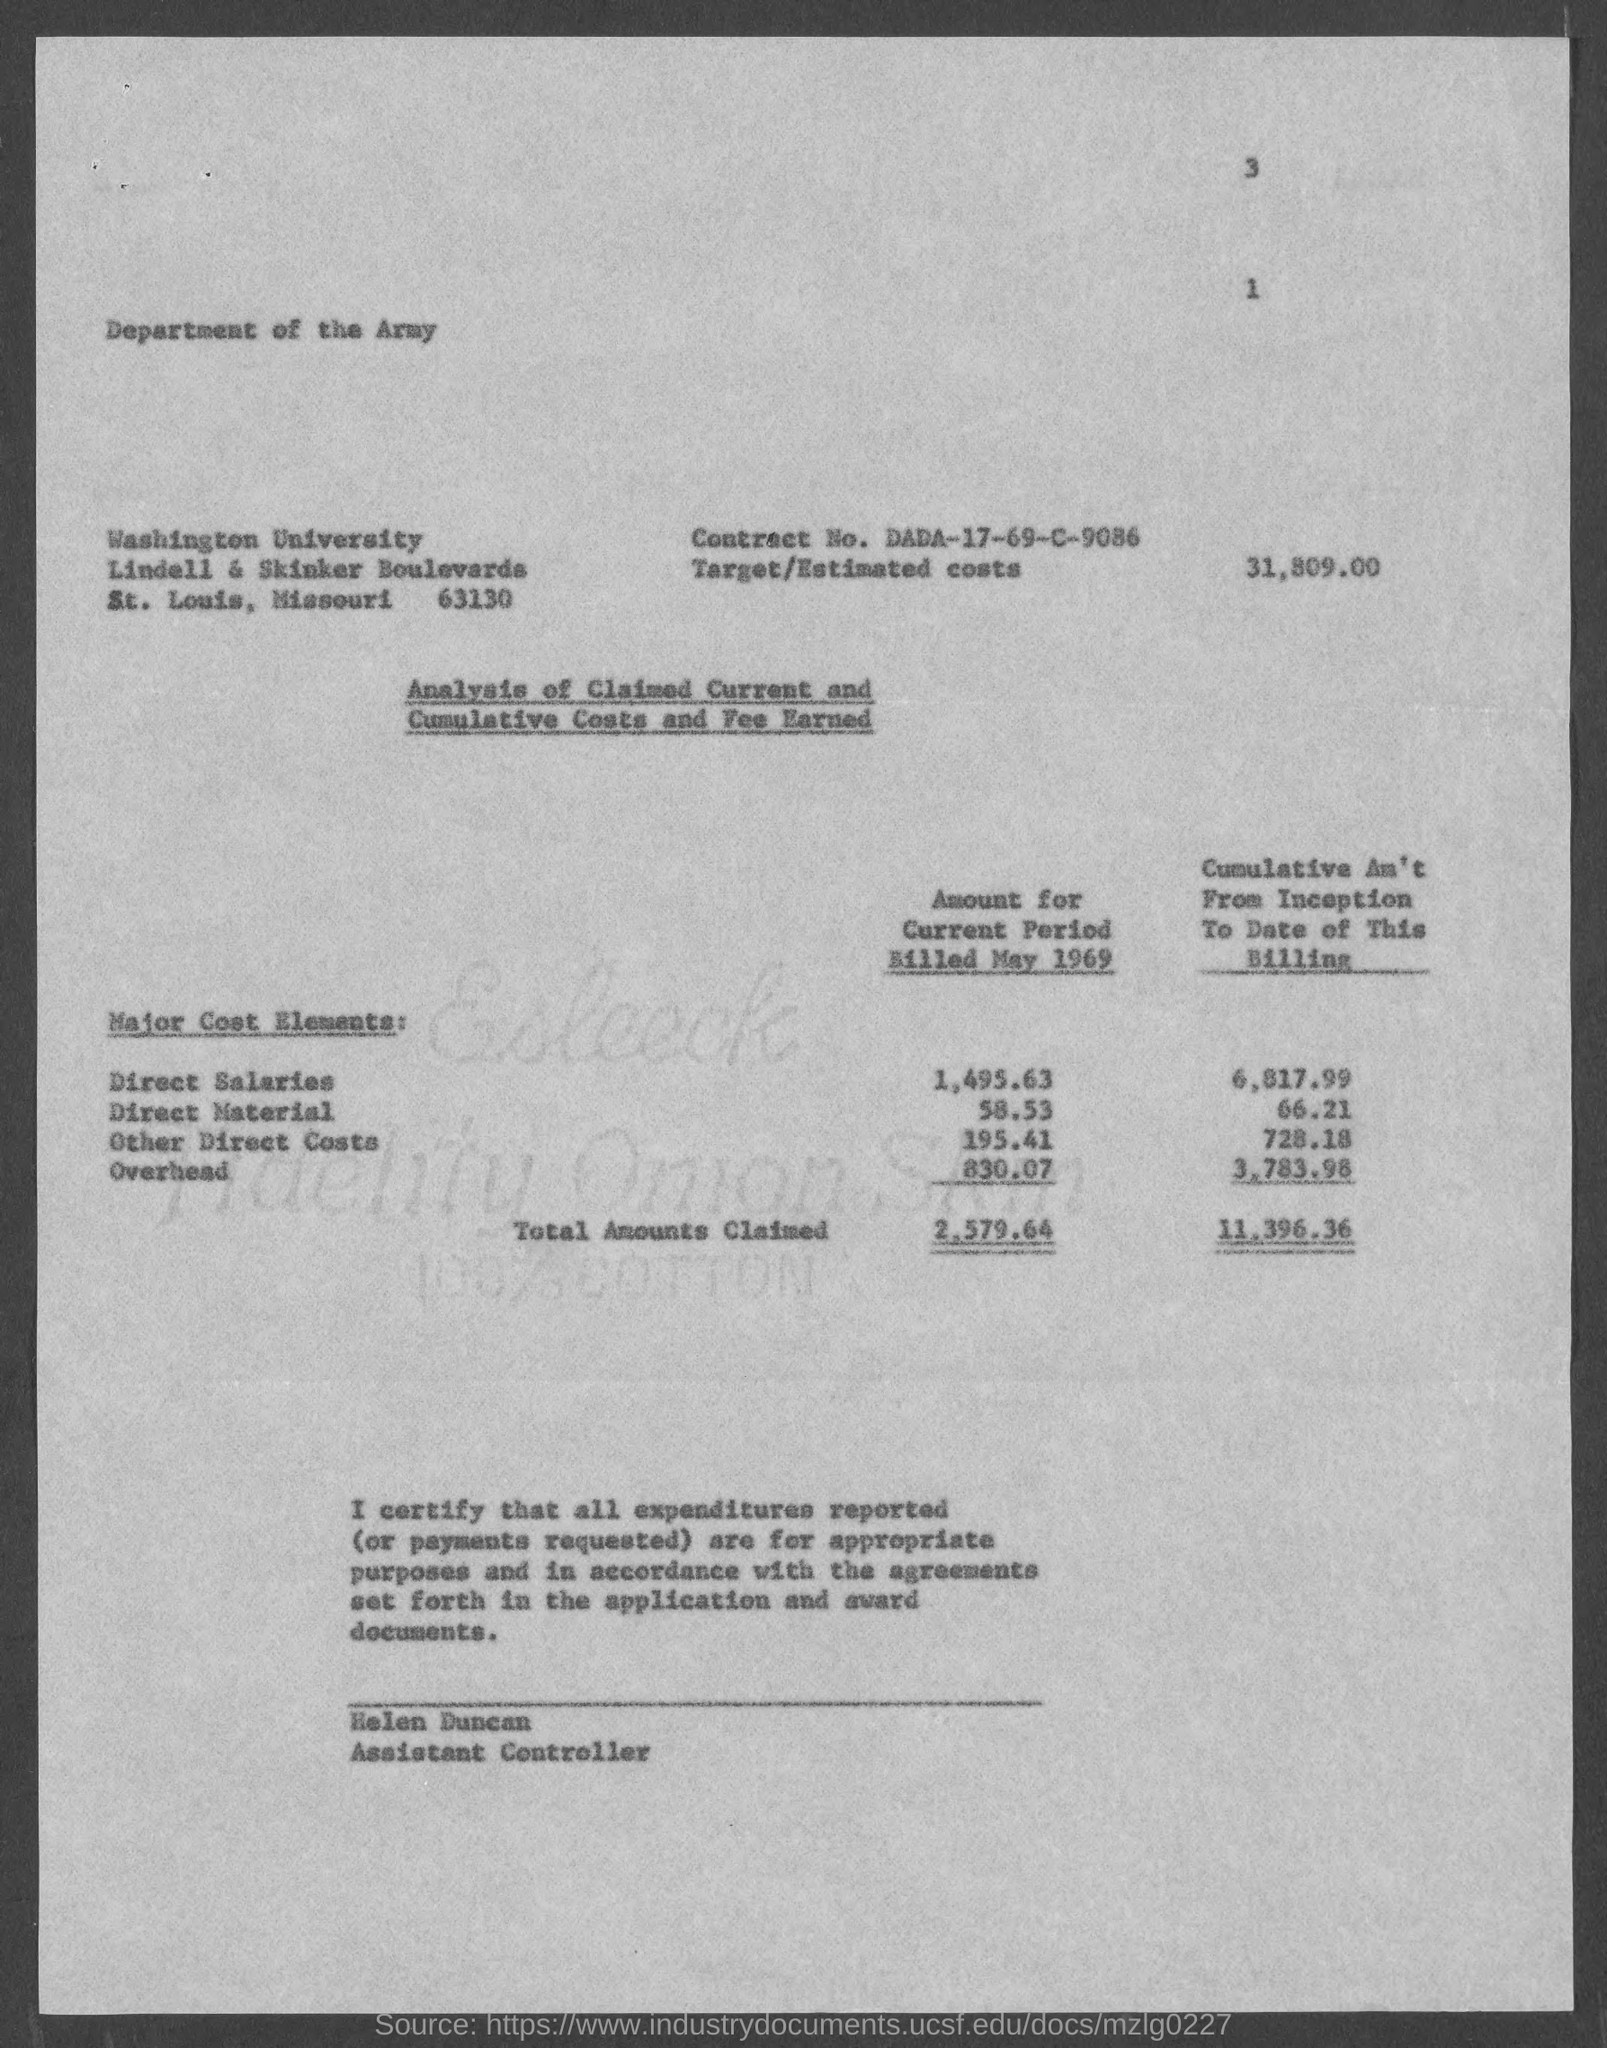What is the Contract No. given in the document?
Offer a terse response. DADA-17-69-C-9086. What is the Target/Estimated costs given in the document?
Make the answer very short. 31,809.00. What is the designation of Helen Duncan?
Offer a very short reply. Assistant Controller. What is the total amount claimed for the current period billed in May 1969?
Your answer should be very brief. 2579.64. What is the total cumulative amount claimed from inception to date of this billing?
Your response must be concise. 11,396.36. What is the direct material amount for the current period billed in May 1969?
Provide a succinct answer. 58.53. What are the direct salaries amount for the current period billed in May 1969?
Your answer should be very brief. 1495.63. 